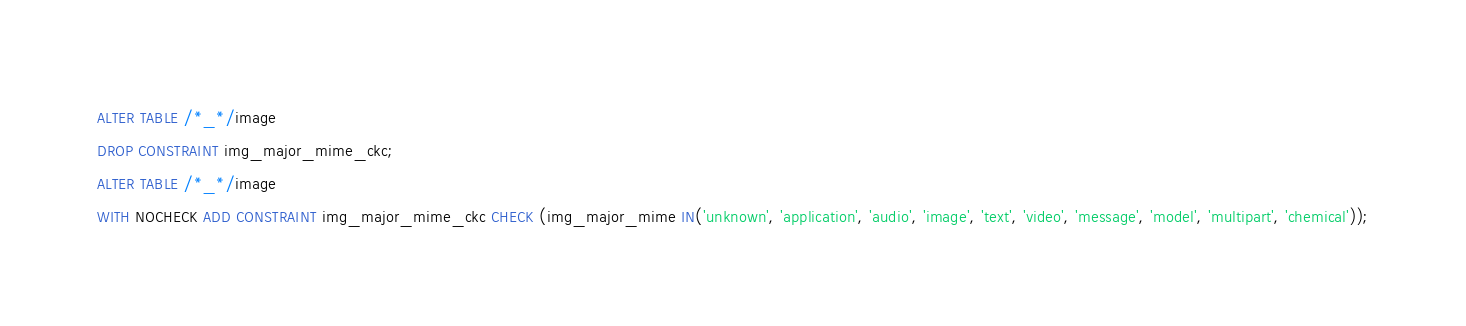Convert code to text. <code><loc_0><loc_0><loc_500><loc_500><_SQL_>ALTER TABLE /*_*/image
DROP CONSTRAINT img_major_mime_ckc;
ALTER TABLE /*_*/image
WITH NOCHECK ADD CONSTRAINT img_major_mime_ckc CHECK (img_major_mime IN('unknown', 'application', 'audio', 'image', 'text', 'video', 'message', 'model', 'multipart', 'chemical'));</code> 